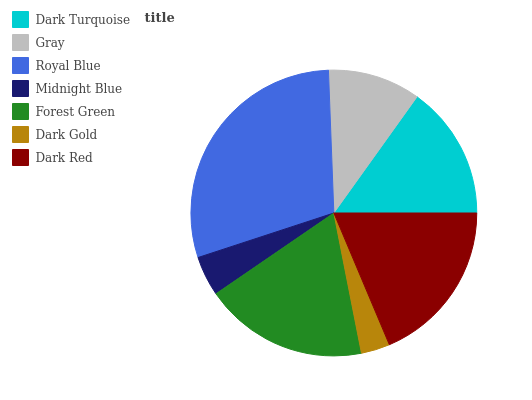Is Dark Gold the minimum?
Answer yes or no. Yes. Is Royal Blue the maximum?
Answer yes or no. Yes. Is Gray the minimum?
Answer yes or no. No. Is Gray the maximum?
Answer yes or no. No. Is Dark Turquoise greater than Gray?
Answer yes or no. Yes. Is Gray less than Dark Turquoise?
Answer yes or no. Yes. Is Gray greater than Dark Turquoise?
Answer yes or no. No. Is Dark Turquoise less than Gray?
Answer yes or no. No. Is Dark Turquoise the high median?
Answer yes or no. Yes. Is Dark Turquoise the low median?
Answer yes or no. Yes. Is Dark Red the high median?
Answer yes or no. No. Is Gray the low median?
Answer yes or no. No. 